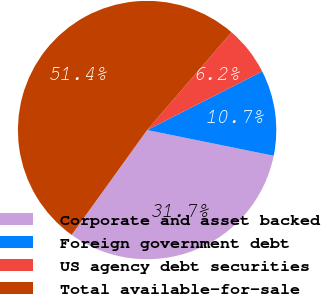Convert chart to OTSL. <chart><loc_0><loc_0><loc_500><loc_500><pie_chart><fcel>Corporate and asset backed<fcel>Foreign government debt<fcel>US agency debt securities<fcel>Total available-for-sale<nl><fcel>31.74%<fcel>10.69%<fcel>6.16%<fcel>51.4%<nl></chart> 